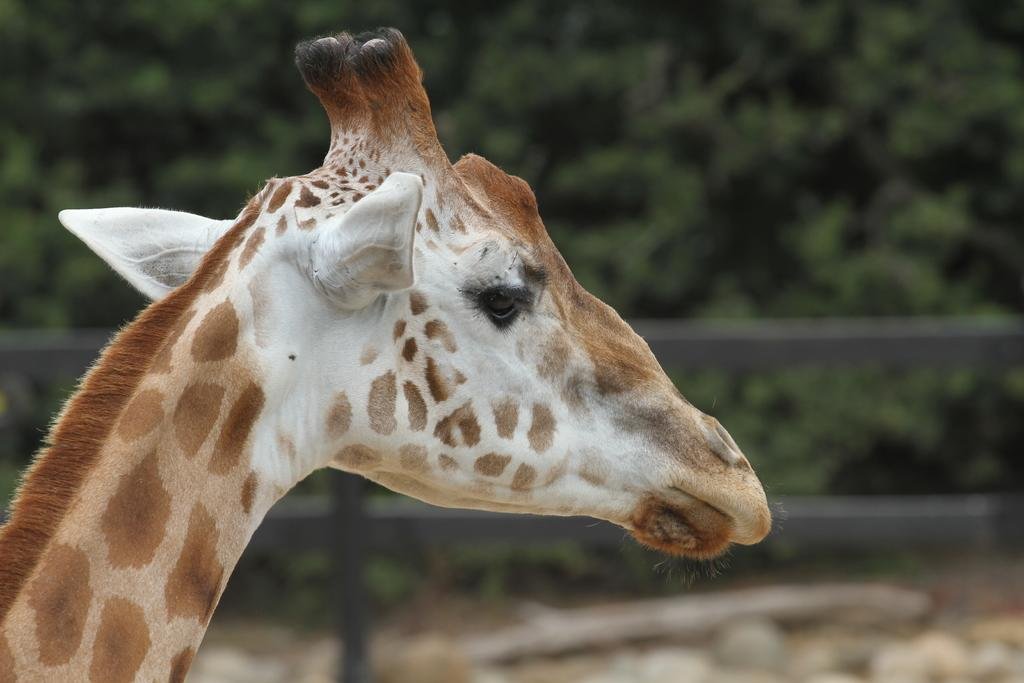What animal is in the foreground of the image? There is a giraffe in the foreground of the image. What can be seen in the background of the image? There are trees and a fence in the background of the image. What type of stove can be seen in the image? There is no stove present in the image; it features a giraffe in the foreground and trees and a fence in the background. 